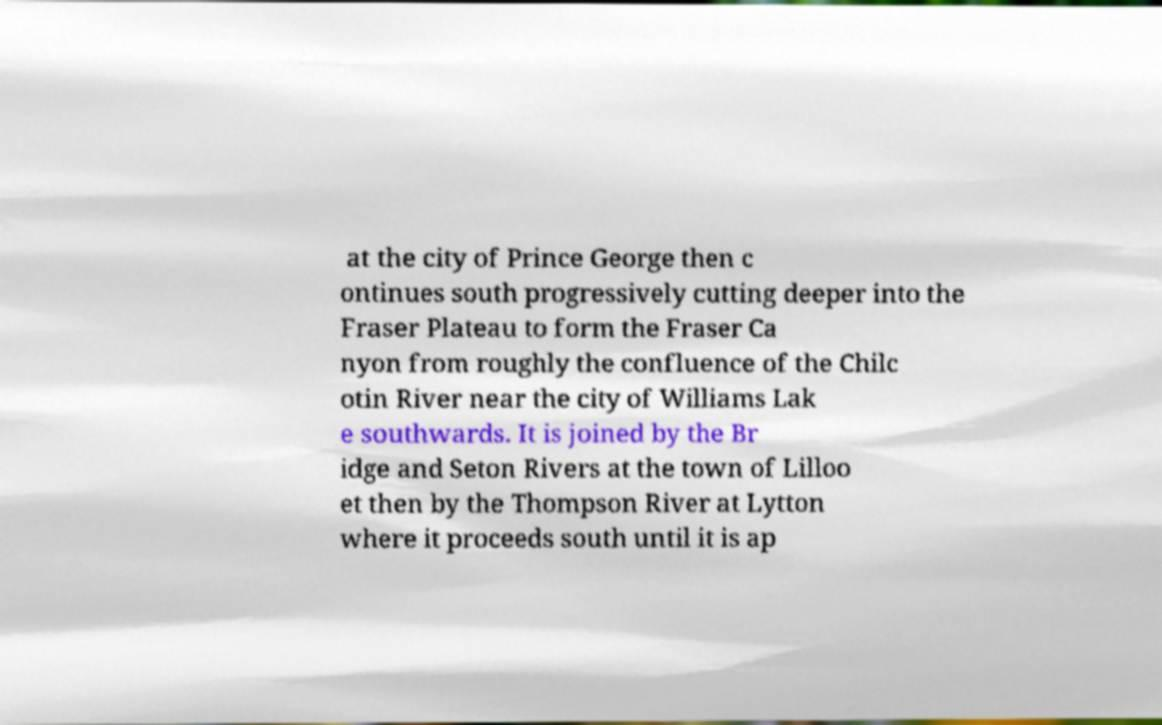I need the written content from this picture converted into text. Can you do that? at the city of Prince George then c ontinues south progressively cutting deeper into the Fraser Plateau to form the Fraser Ca nyon from roughly the confluence of the Chilc otin River near the city of Williams Lak e southwards. It is joined by the Br idge and Seton Rivers at the town of Lilloo et then by the Thompson River at Lytton where it proceeds south until it is ap 